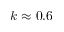Convert formula to latex. <formula><loc_0><loc_0><loc_500><loc_500>k \approx 0 . 6</formula> 